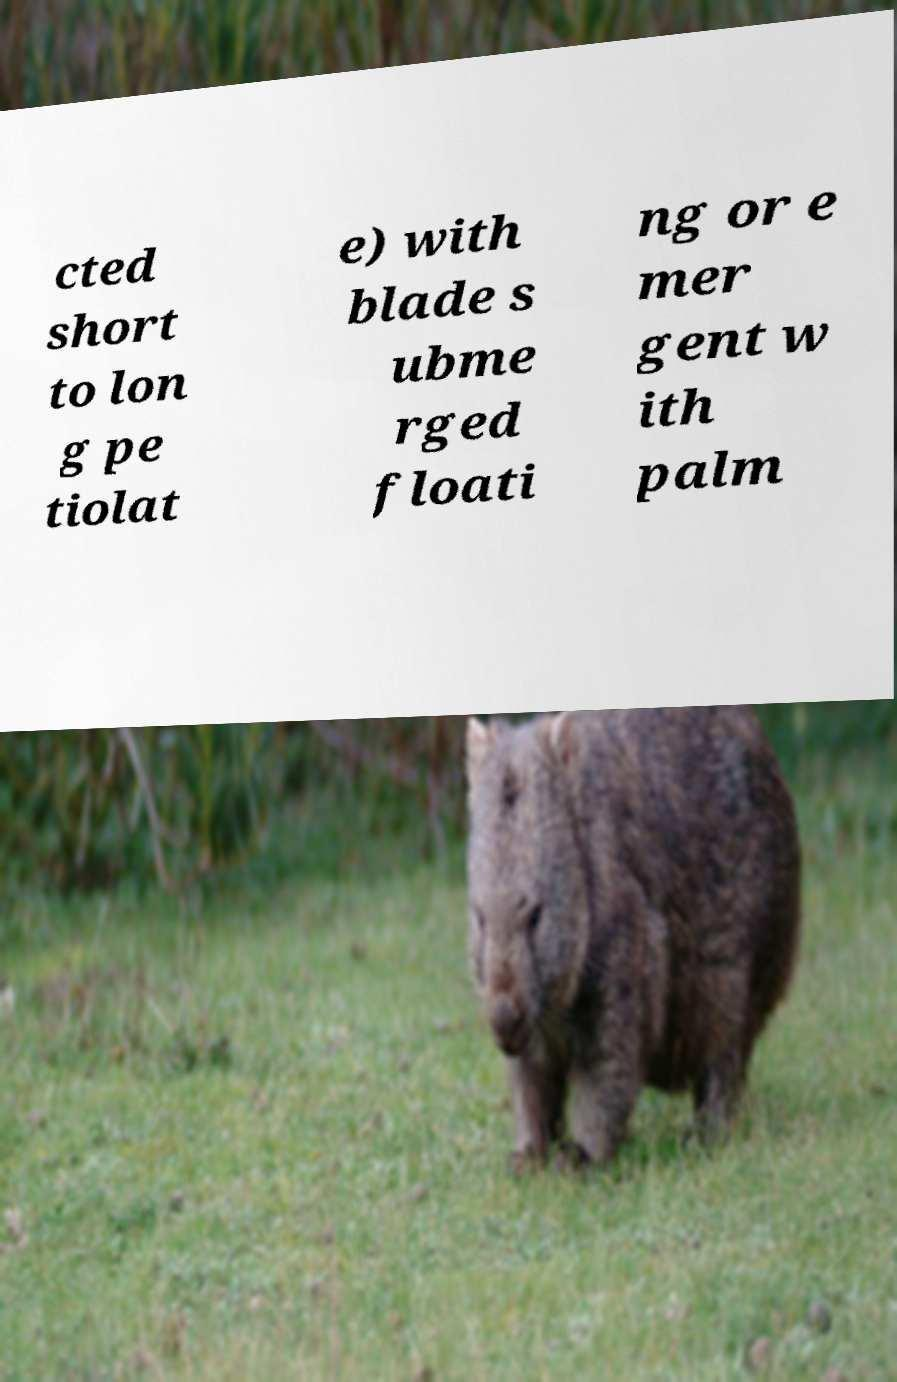Can you read and provide the text displayed in the image?This photo seems to have some interesting text. Can you extract and type it out for me? cted short to lon g pe tiolat e) with blade s ubme rged floati ng or e mer gent w ith palm 